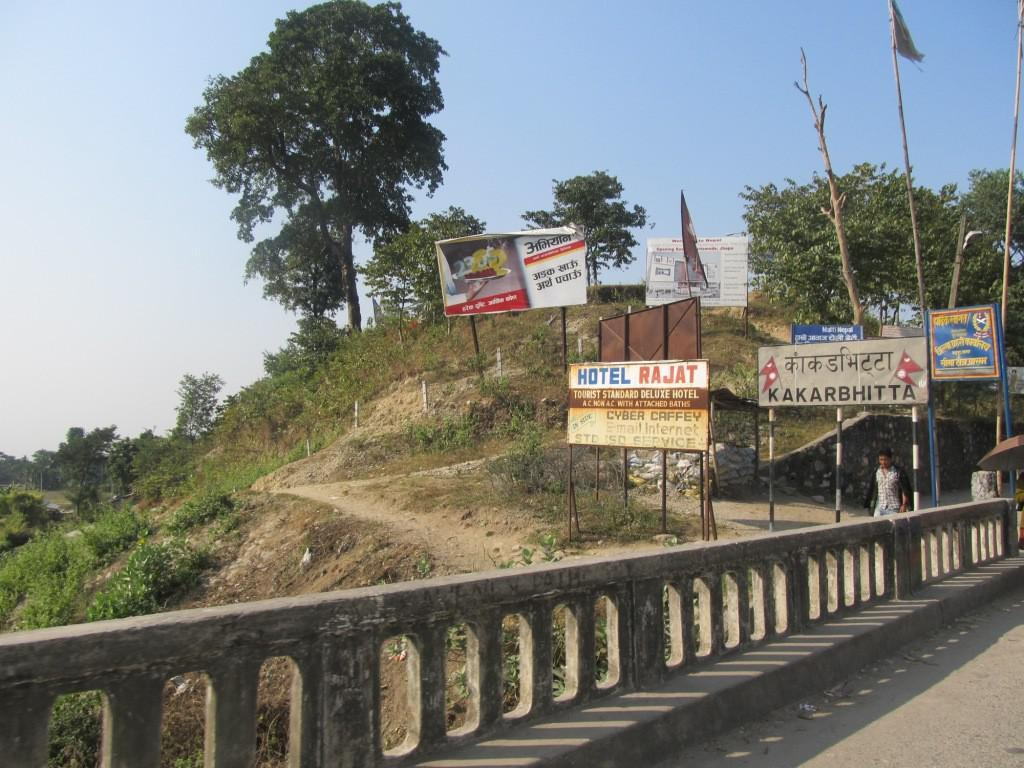Provide a one-sentence caption for the provided image. A sign for a hotel stands on a hill side next to a road. 